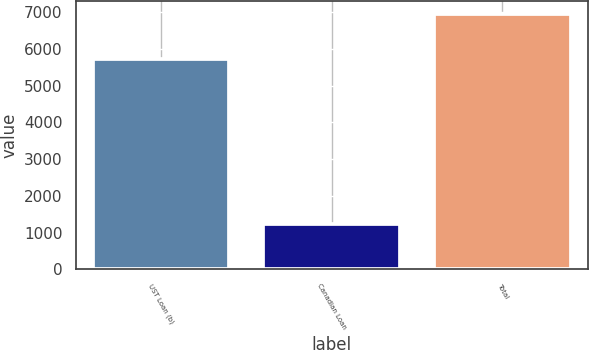<chart> <loc_0><loc_0><loc_500><loc_500><bar_chart><fcel>UST Loan (b)<fcel>Canadian Loan<fcel>Total<nl><fcel>5712<fcel>1233<fcel>6945<nl></chart> 